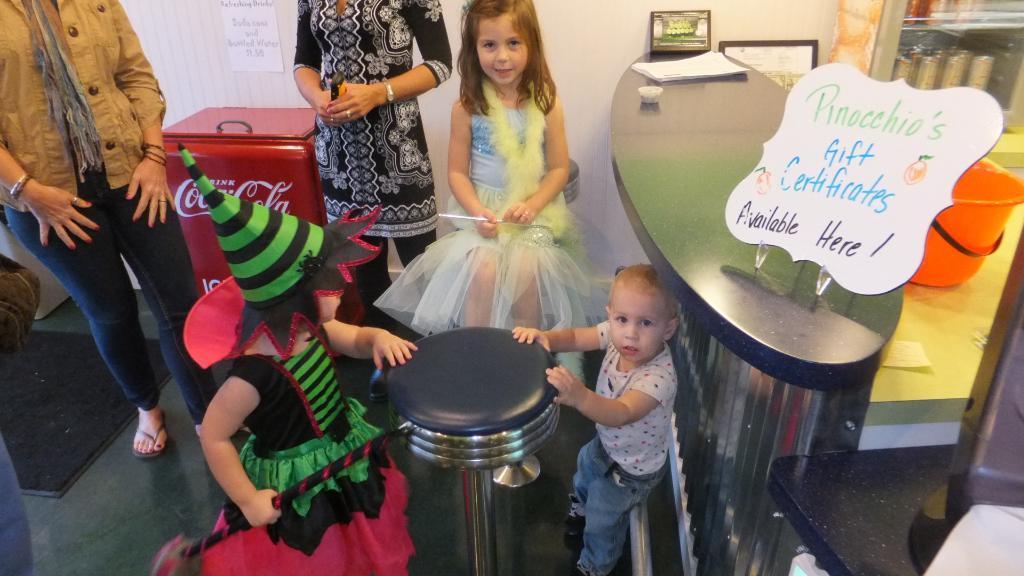Please provide a concise description of this image. In this image we can see people standing on the floor and children are wearing costumes. In the background there are objects arranged in the cupboards, information boards, papers, wall hangings and a bucket. 